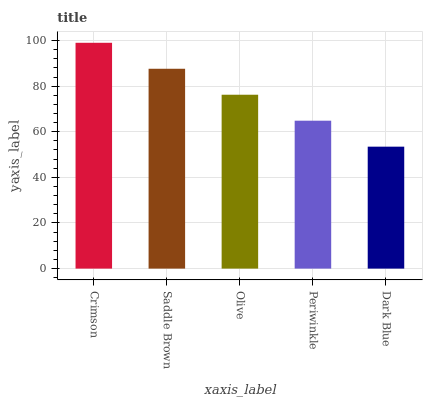Is Dark Blue the minimum?
Answer yes or no. Yes. Is Crimson the maximum?
Answer yes or no. Yes. Is Saddle Brown the minimum?
Answer yes or no. No. Is Saddle Brown the maximum?
Answer yes or no. No. Is Crimson greater than Saddle Brown?
Answer yes or no. Yes. Is Saddle Brown less than Crimson?
Answer yes or no. Yes. Is Saddle Brown greater than Crimson?
Answer yes or no. No. Is Crimson less than Saddle Brown?
Answer yes or no. No. Is Olive the high median?
Answer yes or no. Yes. Is Olive the low median?
Answer yes or no. Yes. Is Dark Blue the high median?
Answer yes or no. No. Is Saddle Brown the low median?
Answer yes or no. No. 